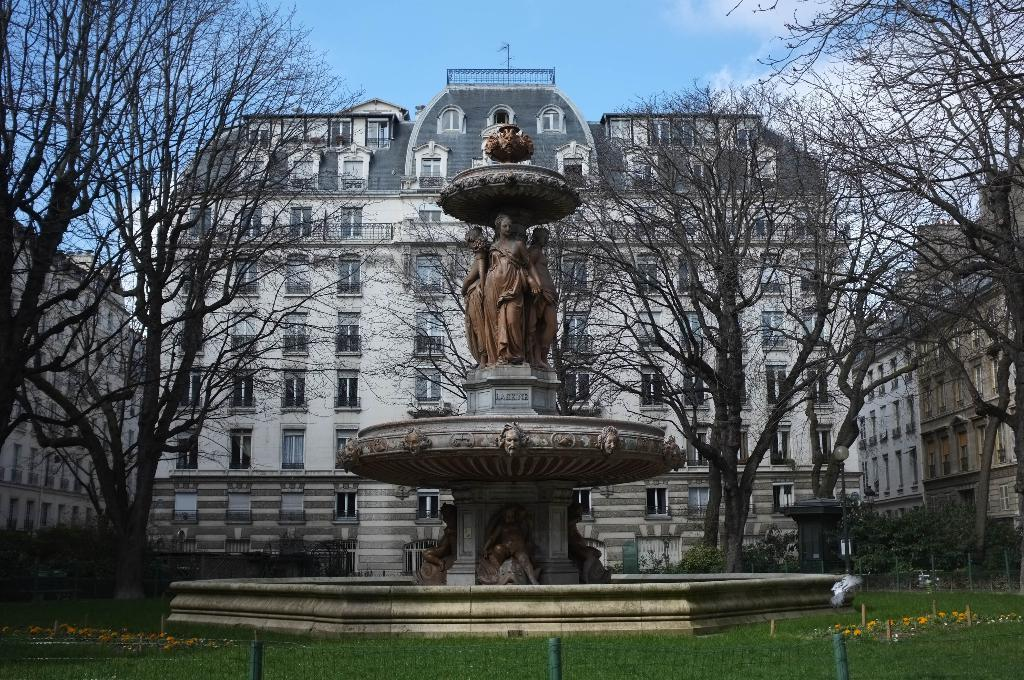What is the main subject of the image? There is a sculpture in the image. What type of structure can be seen in the image? There is fencing in the image. What type of natural environment is visible in the image? There is grass and trees in the image. What can be seen in the background of the image? There are buildings in the background of the image. What type of metal is the carpenter using to build the sky in the image? There is no carpenter or sky present in the image, and no mention of metal being used for any purpose. 